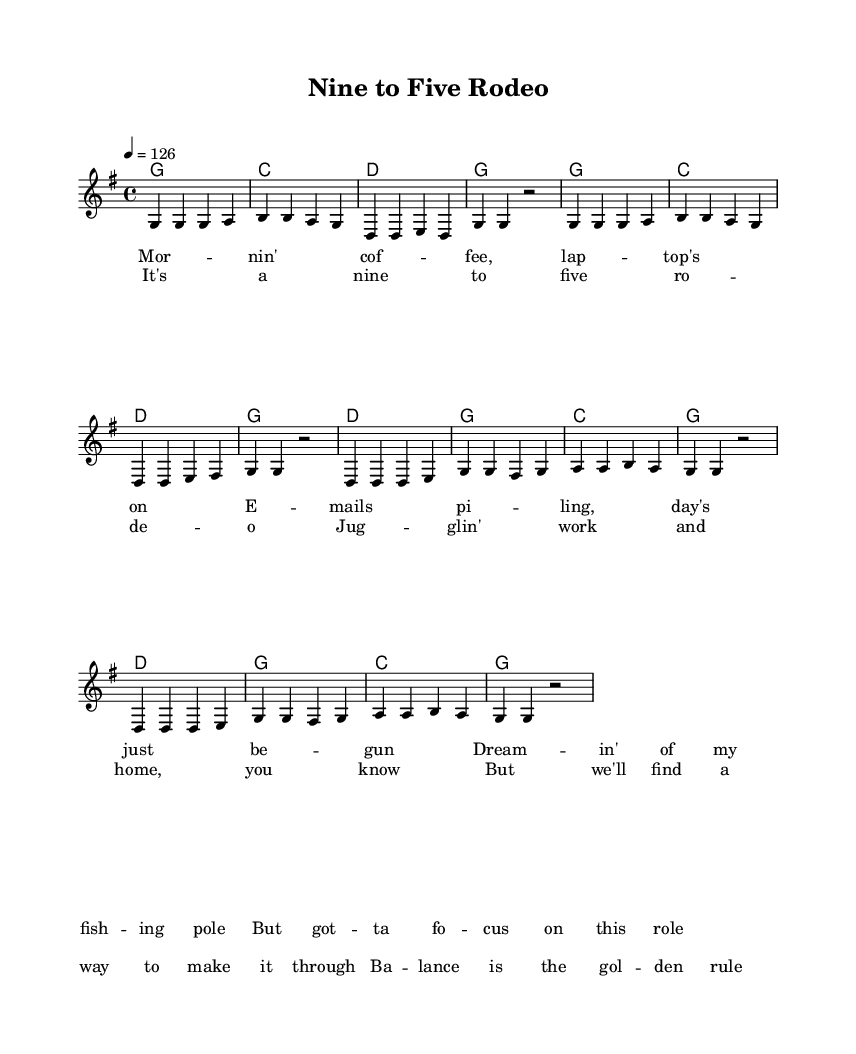What is the key signature of this music? The key signature is G major, indicated by one sharp (F#). This can be determined by looking at the key signature section at the beginning of the score.
Answer: G major What is the time signature of this music? The time signature is 4/4, which means there are four beats in each measure. This is located next to the key signature and indicates the rhythmic structure of the piece.
Answer: 4/4 What is the tempo marking for this piece? The tempo marking is 126 beats per minute, indicated by "4 = 126" at the beginning of the score. This indicates the speed at which the music should be played.
Answer: 126 How many measures are in the verse? There are 8 measures in the verse. The verse is made up of two repeated sections, each containing 4 measures. This can be counted directly from the melody section.
Answer: 8 What lyric starts the chorus? The first lyric of the chorus is "It's a nine to five rodeo." This can be found at the beginning of the chorus lyrics section in the sheet music.
Answer: It's a nine to five rodeo How many unique chords are used in the chorus? There are 3 unique chords used in the chorus: D, G, and C. This can be observed by looking at the chord names above the melody in the chorus section.
Answer: 3 What musical theme is presented in the lyrics? The musical theme presented in the lyrics is balancing work and personal life. This theme is evident from the lyrics discussing working hours and personal aspirations.
Answer: Balancing work and personal life 